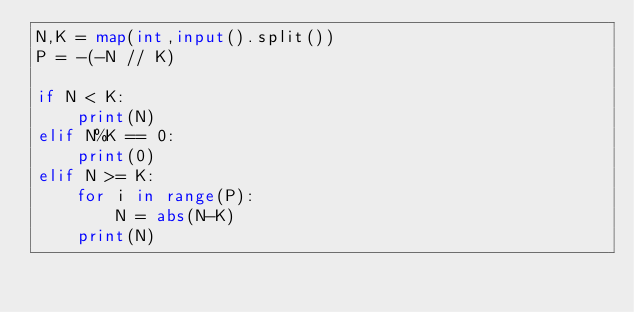Convert code to text. <code><loc_0><loc_0><loc_500><loc_500><_Python_>N,K = map(int,input().split())
P = -(-N // K)

if N < K:
    print(N)
elif N%K == 0:
    print(0)
elif N >= K:
    for i in range(P):
        N = abs(N-K)
    print(N)   </code> 